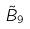<formula> <loc_0><loc_0><loc_500><loc_500>\tilde { B } _ { 9 }</formula> 